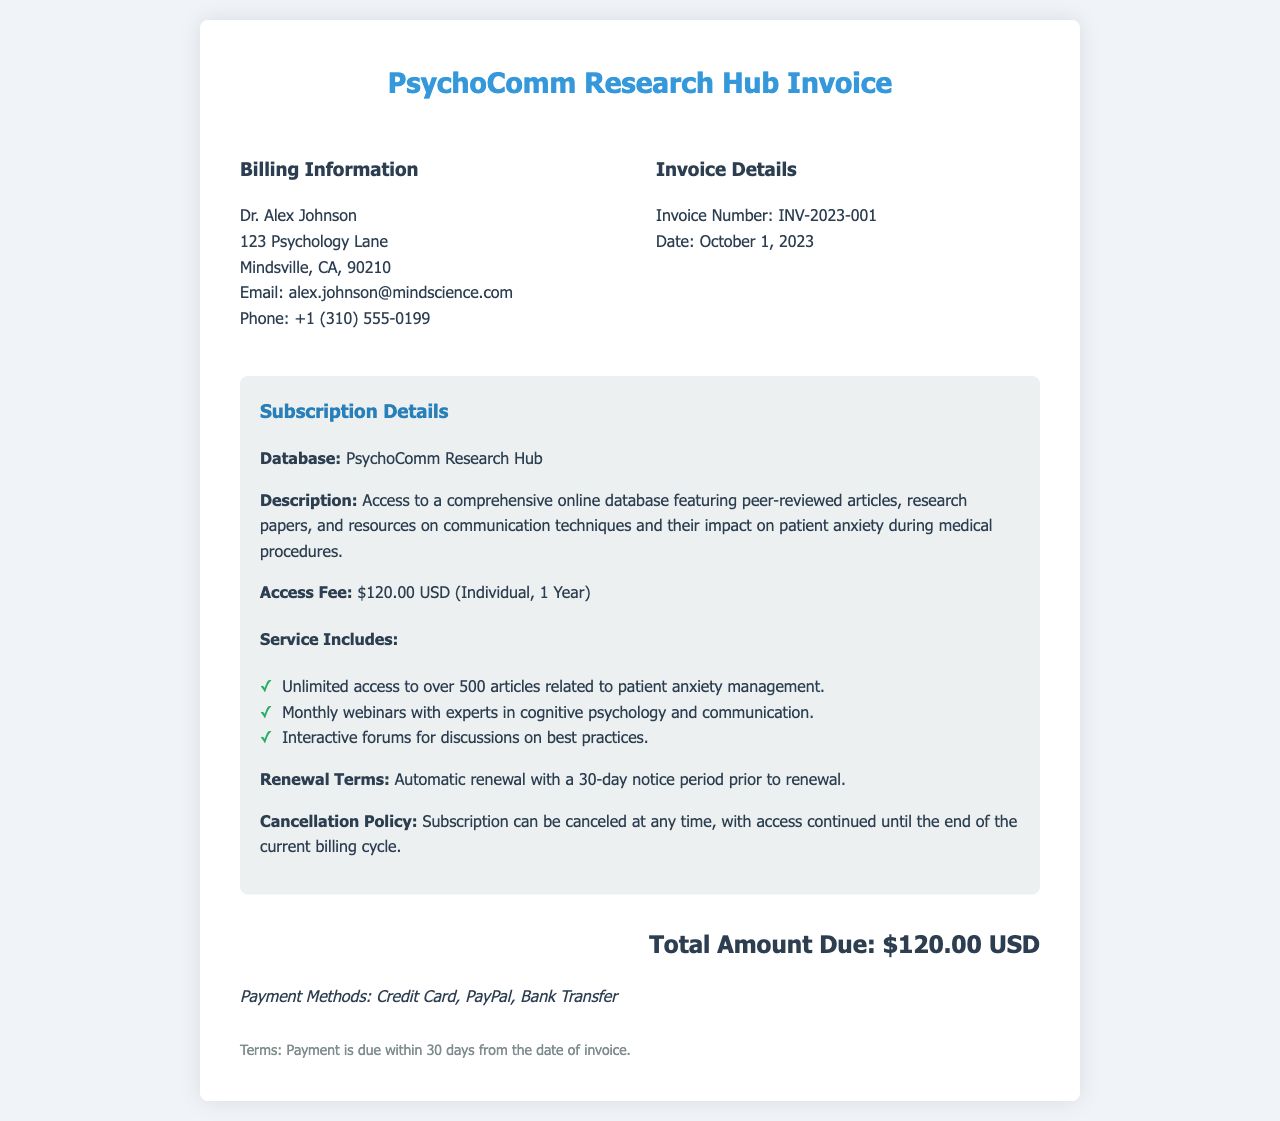what is the invoice number? The invoice number is a specific identifier for this transaction, which is listed in the document as INV-2023-001.
Answer: INV-2023-001 who is the billing recipient? The billing recipient is the individual or organization being billed, which is Dr. Alex Johnson in this case.
Answer: Dr. Alex Johnson what is the access fee? The access fee indicates the cost of the subscription as stated in the invoice, which is $120.00 USD.
Answer: $120.00 USD how long is the subscription duration? The duration of the subscription is mentioned in the document as lasting for 1 Year.
Answer: 1 Year what services are included in the subscription? The services included provide details about what the subscription offers, including access to articles, webinars, and forums.
Answer: Unlimited access to over 500 articles related to patient anxiety management what is the date of the invoice? The date specifies when the invoice was issued, which is found in the document as October 1, 2023.
Answer: October 1, 2023 what is the cancellation policy? The cancellation policy outlines the terms regarding how and when the subscription can be terminated, which states that the subscription can be canceled at any time.
Answer: Subscription can be canceled at any time what payment methods are accepted? The payment methods indicate how payment can be made for the subscription, which includes Credit Card, PayPal, and Bank Transfer.
Answer: Credit Card, PayPal, Bank Transfer what happens upon renewal of the subscription? The renewal terms describe the process of renewing the subscription, which involves automatic renewal with a notice period of 30 days.
Answer: Automatic renewal with a 30-day notice period prior to renewal 